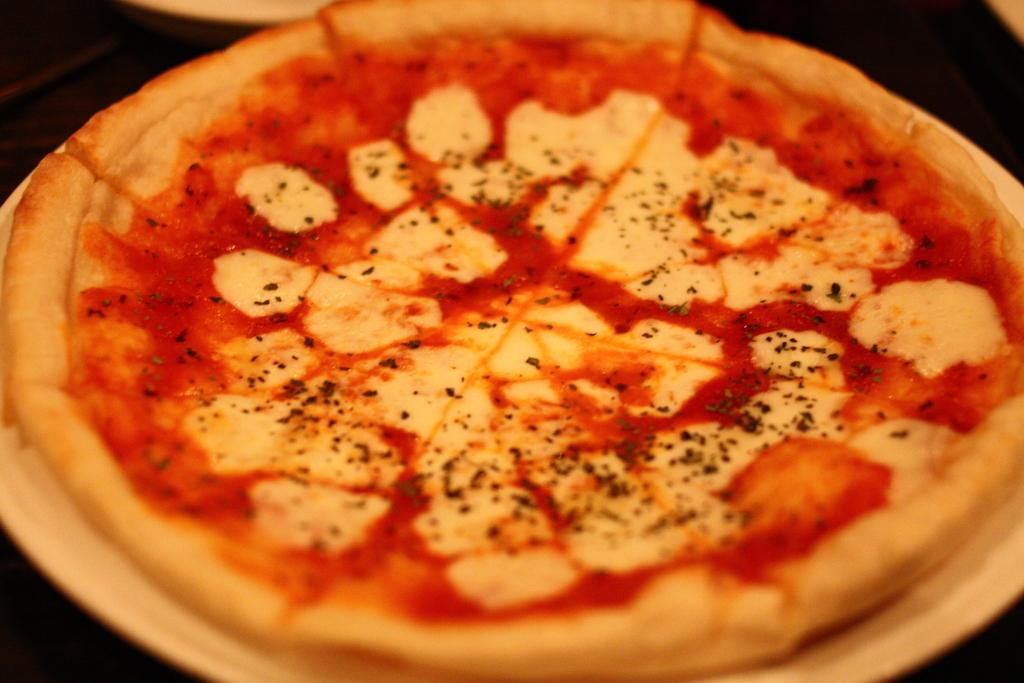What is on the plate in the image? There is pizza on the plate in the image. What is the color of the background in the image? The background of the image is dark. What type of dress is the insect wearing in the image? There is no insect or dress present in the image. 